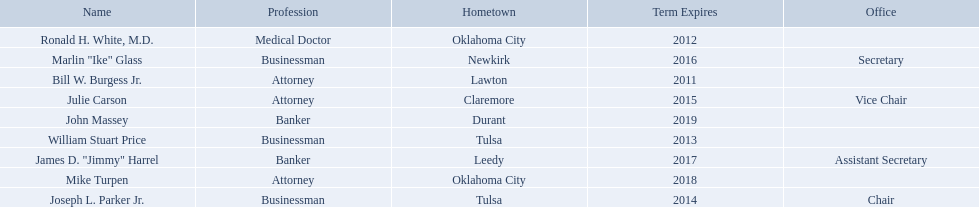What businessmen were born in tulsa? William Stuart Price, Joseph L. Parker Jr. Which man, other than price, was born in tulsa? Joseph L. Parker Jr. Who are the state regents? Bill W. Burgess Jr., Ronald H. White, M.D., William Stuart Price, Joseph L. Parker Jr., Julie Carson, Marlin "Ike" Glass, James D. "Jimmy" Harrel, Mike Turpen, John Massey. Of those state regents, who is from the same hometown as ronald h. white, m.d.? Mike Turpen. 